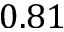<formula> <loc_0><loc_0><loc_500><loc_500>0 . 8 1</formula> 